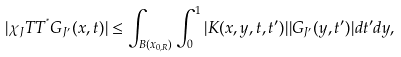<formula> <loc_0><loc_0><loc_500><loc_500>| \chi _ { J } T T ^ { ^ { * } } G _ { J ^ { \prime } } ( x , t ) | \leq \int _ { B ( x _ { 0 , R } ) } { \int _ { 0 } ^ { 1 } | K ( x , y , t , t ^ { \prime } ) | | G _ { J ^ { \prime } } ( y , t ^ { \prime } ) | d t ^ { \prime } d y , }</formula> 